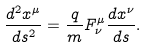Convert formula to latex. <formula><loc_0><loc_0><loc_500><loc_500>\frac { d ^ { 2 } x ^ { \mu } } { d s ^ { 2 } } = \frac { q } { m } F _ { \nu } ^ { \mu } \frac { d x ^ { \nu } } { d s } .</formula> 